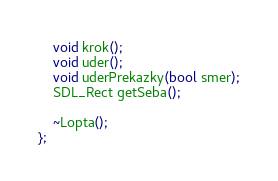<code> <loc_0><loc_0><loc_500><loc_500><_C_>	void krok();
	void uder();
	void uderPrekazky(bool smer);
	SDL_Rect getSeba();

	~Lopta();
};

</code> 